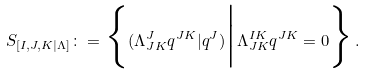Convert formula to latex. <formula><loc_0><loc_0><loc_500><loc_500>S _ { [ I , J , K | \Lambda ] } \colon = \Big \{ ( \Lambda ^ { J } _ { J K } q ^ { J K } | q ^ { J } ) \Big | \Lambda ^ { I K } _ { J K } q ^ { J K } = 0 \Big \} \, .</formula> 